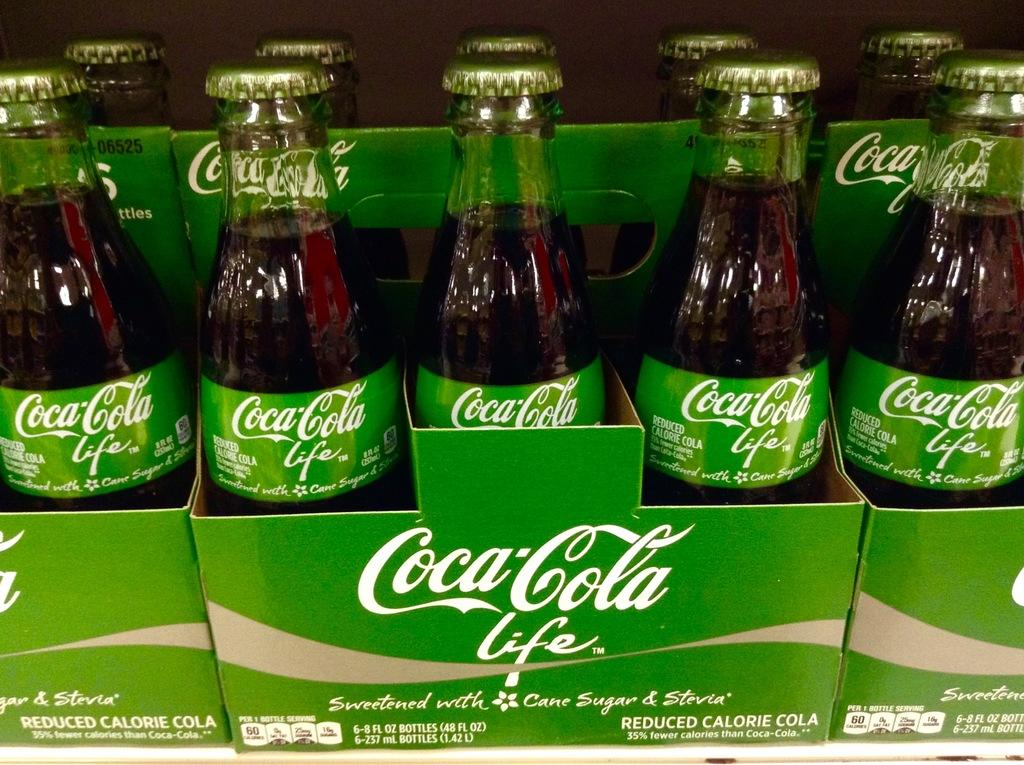<image>
Offer a succinct explanation of the picture presented. the words coca cola that are on some bottles 